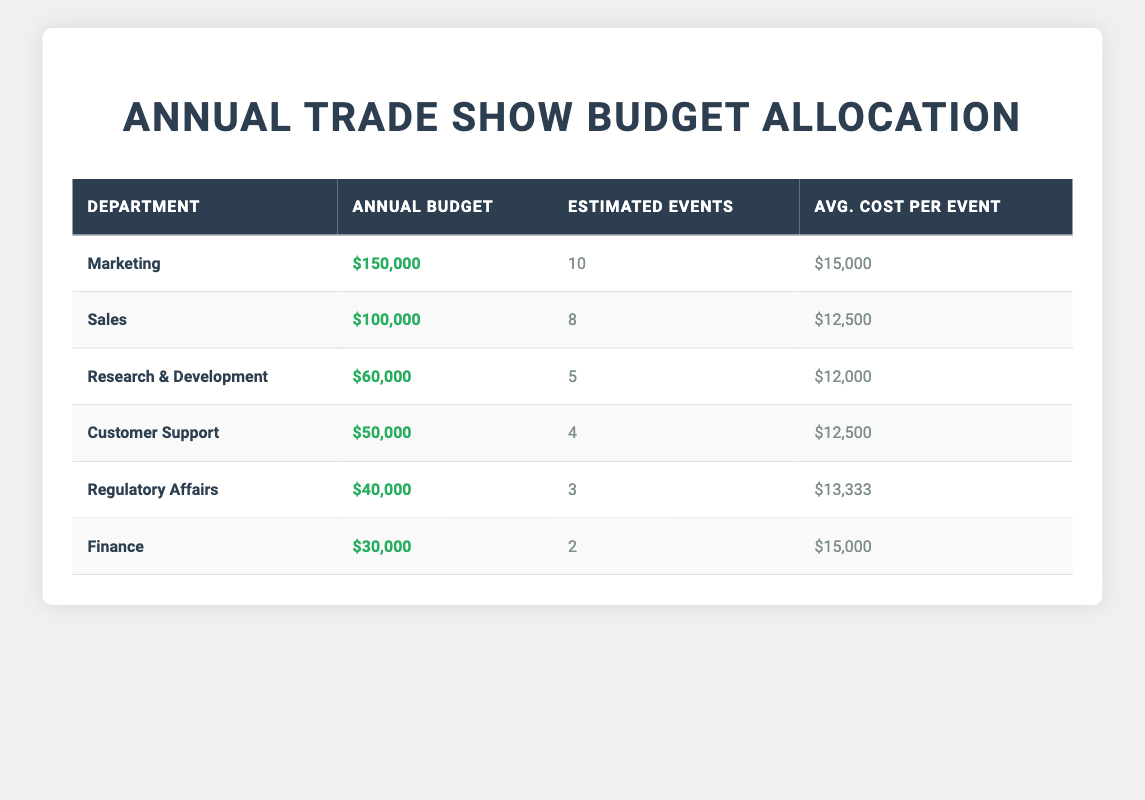What is the annual budget allocation for the Marketing department? The table shows the annual budget allocation for each department. For the Marketing department, the value listed is $150,000.
Answer: $150,000 How many estimated events does the Sales department plan to attend? Referring to the Sales department row in the table, the estimated number of events is indicated as 8.
Answer: 8 What is the average cost per event for Research & Development? The table specifies the average cost per event for Research & Development as $12,000.
Answer: $12,000 Which department has the highest annual budget allocation? By comparing the annual budget allocations from all departments in the table, Marketing has the highest at $150,000.
Answer: Marketing How much budget does the Regulatory Affairs department have compared to the Finance department? The Regulatory Affairs department has an annual budget allocation of $40,000, while Finance has $30,000. Therefore, Regulatory Affairs has $10,000 more than Finance.
Answer: $10,000 What is the total annual budget allocation for all departments combined? To find the total, sum all the annual budget allocations: $150,000 + $100,000 + $60,000 + $50,000 + $40,000 + $30,000 = $430,000.
Answer: $430,000 How many events are estimated for the Customer Support department? The Customer Support department row indicates that the estimated number of events is 4.
Answer: 4 Are the average costs per event for the Sales and Customer Support departments the same? The average cost per event for Sales is $12,500, and for Customer Support, it is also $12,500, meaning they are equal.
Answer: Yes What is the total budget allocated for the Marketing and Sales departments combined? Adding the Marketing ($150,000) and Sales ($100,000) budget allocations yields $250,000.
Answer: $250,000 What is the difference in average cost per event between Customer Support and Regulatory Affairs? The average cost per event for Customer Support is $12,500 and for Regulatory Affairs is $13,333. The difference is $13,333 - $12,500 = $833.
Answer: $833 